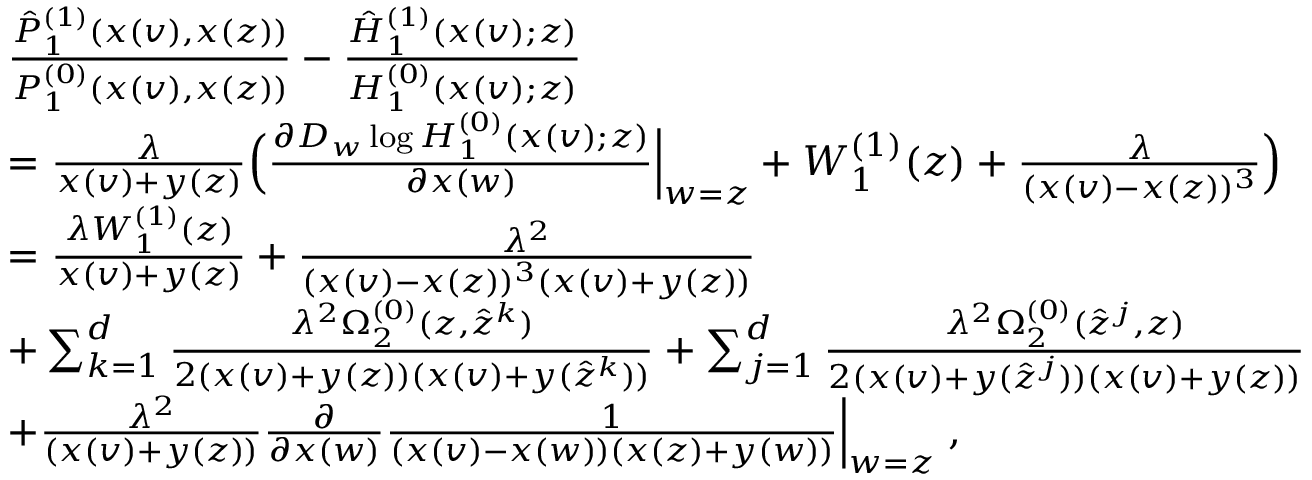Convert formula to latex. <formula><loc_0><loc_0><loc_500><loc_500>\begin{array} { r l } & { \frac { \hat { P } _ { 1 } ^ { ( 1 ) } ( x ( v ) , x ( z ) ) } { P _ { 1 } ^ { ( 0 ) } ( x ( v ) , x ( z ) ) } - \frac { \hat { H } _ { 1 } ^ { ( 1 ) } ( x ( v ) ; z ) } { H _ { 1 } ^ { ( 0 ) } ( x ( v ) ; z ) } } \\ & { = \frac { \lambda } { x ( v ) + y ( z ) } \left ( \frac { \partial D _ { w } \log H _ { 1 } ^ { ( 0 ) } ( x ( v ) ; z ) } { \partial x ( w ) } \left | _ { w = z } + W _ { 1 } ^ { ( 1 ) } ( z ) + \frac { \lambda } { ( x ( v ) - x ( z ) ) ^ { 3 } } \right ) } \\ & { = \frac { \lambda W _ { 1 } ^ { ( 1 ) } ( z ) } { x ( v ) + y ( z ) } + \frac { \lambda ^ { 2 } } { ( x ( v ) - x ( z ) ) ^ { 3 } ( x ( v ) + y ( z ) ) } } \\ & { + \sum _ { k = 1 } ^ { d } \frac { \lambda ^ { 2 } \Omega _ { 2 } ^ { ( 0 ) } ( z , \hat { z } ^ { k } ) } { 2 ( x ( v ) + y ( z ) ) ( x ( v ) + y ( \hat { z } ^ { k } ) ) } + \sum _ { j = 1 } ^ { d } \frac { \lambda ^ { 2 } \Omega _ { 2 } ^ { ( 0 ) } ( \hat { z } ^ { j } , z ) } { 2 ( x ( v ) + y ( \hat { z } ^ { j } ) ) ( x ( v ) + y ( z ) ) } } \\ & { + \frac { \lambda ^ { 2 } } { ( x ( v ) + y ( z ) ) } \frac { \partial } { \partial x ( w ) } \frac { 1 } { ( x ( v ) - x ( w ) ) ( x ( z ) + y ( w ) ) } \right | _ { w = z } \, , } \end{array}</formula> 